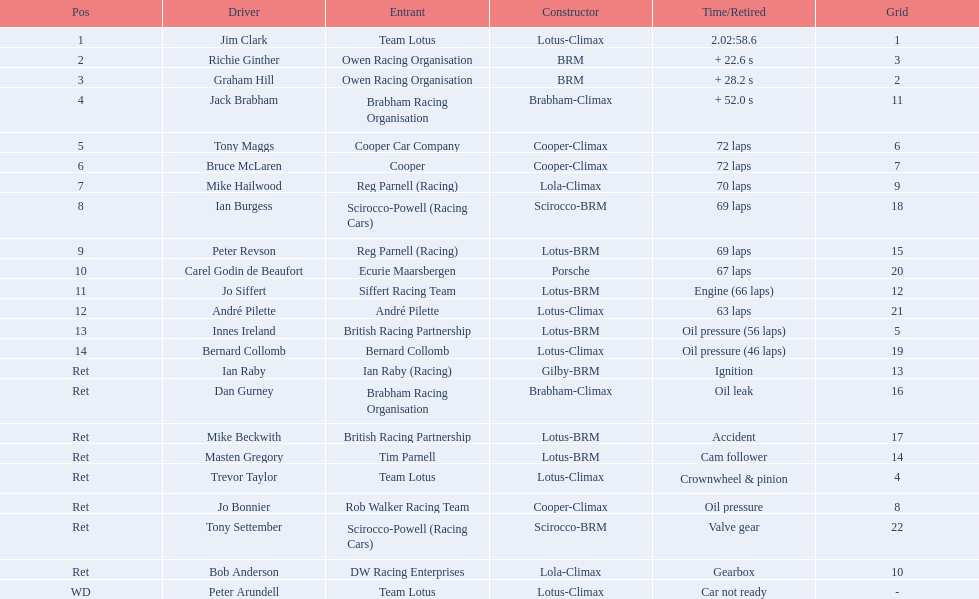What are the listed driver names? Jim Clark, Richie Ginther, Graham Hill, Jack Brabham, Tony Maggs, Bruce McLaren, Mike Hailwood, Ian Burgess, Peter Revson, Carel Godin de Beaufort, Jo Siffert, André Pilette, Innes Ireland, Bernard Collomb, Ian Raby, Dan Gurney, Mike Beckwith, Masten Gregory, Trevor Taylor, Jo Bonnier, Tony Settember, Bob Anderson, Peter Arundell. Which are tony maggs and jo siffert? Tony Maggs, Jo Siffert. Parse the table in full. {'header': ['Pos', 'Driver', 'Entrant', 'Constructor', 'Time/Retired', 'Grid'], 'rows': [['1', 'Jim Clark', 'Team Lotus', 'Lotus-Climax', '2.02:58.6', '1'], ['2', 'Richie Ginther', 'Owen Racing Organisation', 'BRM', '+ 22.6 s', '3'], ['3', 'Graham Hill', 'Owen Racing Organisation', 'BRM', '+ 28.2 s', '2'], ['4', 'Jack Brabham', 'Brabham Racing Organisation', 'Brabham-Climax', '+ 52.0 s', '11'], ['5', 'Tony Maggs', 'Cooper Car Company', 'Cooper-Climax', '72 laps', '6'], ['6', 'Bruce McLaren', 'Cooper', 'Cooper-Climax', '72 laps', '7'], ['7', 'Mike Hailwood', 'Reg Parnell (Racing)', 'Lola-Climax', '70 laps', '9'], ['8', 'Ian Burgess', 'Scirocco-Powell (Racing Cars)', 'Scirocco-BRM', '69 laps', '18'], ['9', 'Peter Revson', 'Reg Parnell (Racing)', 'Lotus-BRM', '69 laps', '15'], ['10', 'Carel Godin de Beaufort', 'Ecurie Maarsbergen', 'Porsche', '67 laps', '20'], ['11', 'Jo Siffert', 'Siffert Racing Team', 'Lotus-BRM', 'Engine (66 laps)', '12'], ['12', 'André Pilette', 'André Pilette', 'Lotus-Climax', '63 laps', '21'], ['13', 'Innes Ireland', 'British Racing Partnership', 'Lotus-BRM', 'Oil pressure (56 laps)', '5'], ['14', 'Bernard Collomb', 'Bernard Collomb', 'Lotus-Climax', 'Oil pressure (46 laps)', '19'], ['Ret', 'Ian Raby', 'Ian Raby (Racing)', 'Gilby-BRM', 'Ignition', '13'], ['Ret', 'Dan Gurney', 'Brabham Racing Organisation', 'Brabham-Climax', 'Oil leak', '16'], ['Ret', 'Mike Beckwith', 'British Racing Partnership', 'Lotus-BRM', 'Accident', '17'], ['Ret', 'Masten Gregory', 'Tim Parnell', 'Lotus-BRM', 'Cam follower', '14'], ['Ret', 'Trevor Taylor', 'Team Lotus', 'Lotus-Climax', 'Crownwheel & pinion', '4'], ['Ret', 'Jo Bonnier', 'Rob Walker Racing Team', 'Cooper-Climax', 'Oil pressure', '8'], ['Ret', 'Tony Settember', 'Scirocco-Powell (Racing Cars)', 'Scirocco-BRM', 'Valve gear', '22'], ['Ret', 'Bob Anderson', 'DW Racing Enterprises', 'Lola-Climax', 'Gearbox', '10'], ['WD', 'Peter Arundell', 'Team Lotus', 'Lotus-Climax', 'Car not ready', '-']]} What are their corresponding finishing places? 5, 11. Whose is better? Tony Maggs. 